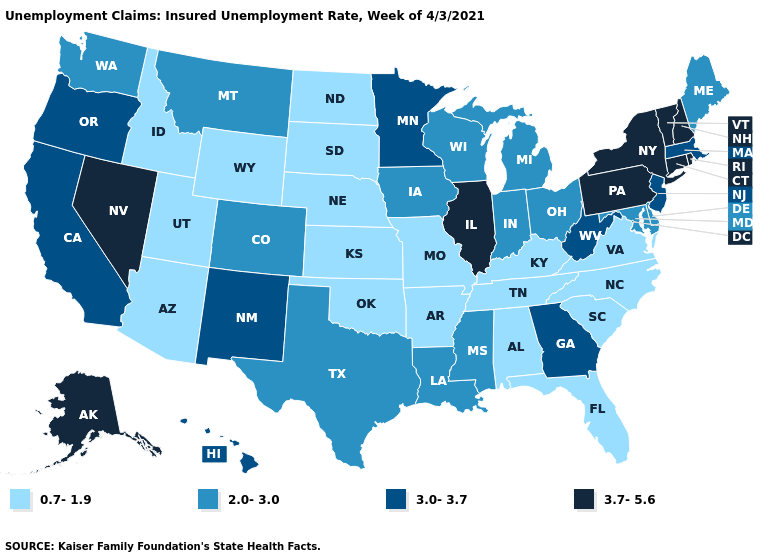What is the highest value in the USA?
Short answer required. 3.7-5.6. Does North Carolina have the lowest value in the South?
Give a very brief answer. Yes. How many symbols are there in the legend?
Short answer required. 4. Name the states that have a value in the range 3.7-5.6?
Short answer required. Alaska, Connecticut, Illinois, Nevada, New Hampshire, New York, Pennsylvania, Rhode Island, Vermont. Which states have the lowest value in the South?
Keep it brief. Alabama, Arkansas, Florida, Kentucky, North Carolina, Oklahoma, South Carolina, Tennessee, Virginia. Name the states that have a value in the range 2.0-3.0?
Keep it brief. Colorado, Delaware, Indiana, Iowa, Louisiana, Maine, Maryland, Michigan, Mississippi, Montana, Ohio, Texas, Washington, Wisconsin. What is the highest value in states that border New York?
Quick response, please. 3.7-5.6. What is the highest value in the USA?
Quick response, please. 3.7-5.6. Among the states that border Utah , which have the lowest value?
Keep it brief. Arizona, Idaho, Wyoming. Does Mississippi have the same value as New Mexico?
Concise answer only. No. Name the states that have a value in the range 3.0-3.7?
Keep it brief. California, Georgia, Hawaii, Massachusetts, Minnesota, New Jersey, New Mexico, Oregon, West Virginia. Among the states that border Missouri , which have the lowest value?
Be succinct. Arkansas, Kansas, Kentucky, Nebraska, Oklahoma, Tennessee. What is the value of Nevada?
Write a very short answer. 3.7-5.6. Does Arizona have a lower value than Nebraska?
Be succinct. No. What is the value of Connecticut?
Concise answer only. 3.7-5.6. 